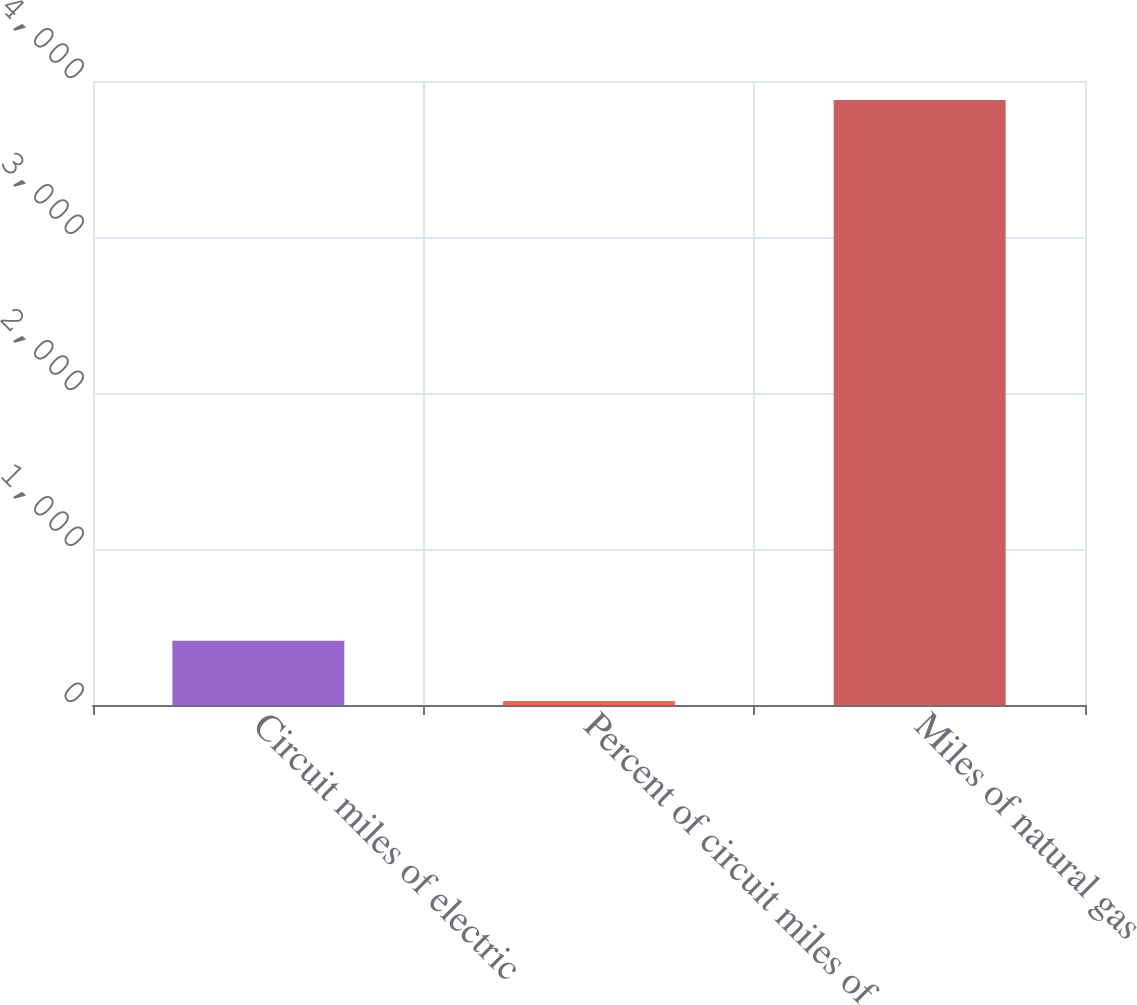Convert chart to OTSL. <chart><loc_0><loc_0><loc_500><loc_500><bar_chart><fcel>Circuit miles of electric<fcel>Percent of circuit miles of<fcel>Miles of natural gas<nl><fcel>411.2<fcel>26<fcel>3878<nl></chart> 